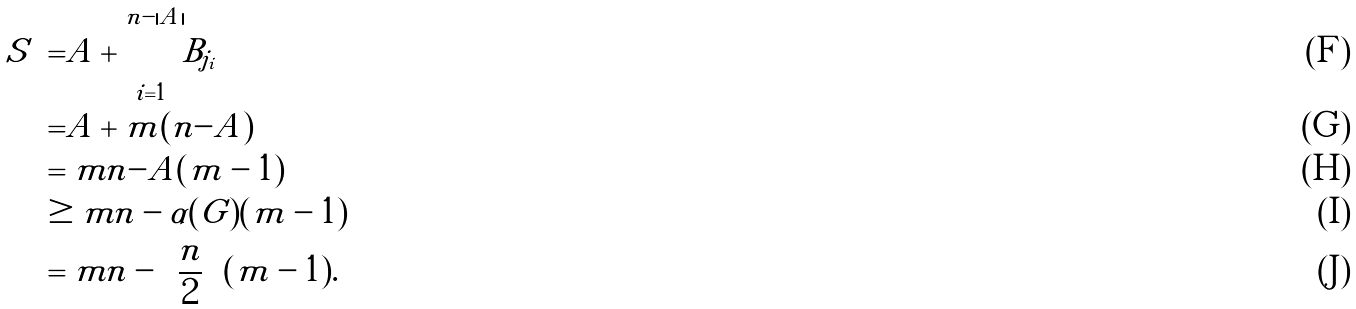Convert formula to latex. <formula><loc_0><loc_0><loc_500><loc_500>| S | & = | A | + \sum _ { i = 1 } ^ { n - | A | } | B _ { j _ { i } } | \\ & = | A | + m ( n - | A | ) \\ & = m n - | A | ( m - 1 ) \\ & \geq m n - \alpha ( G ) ( m - 1 ) \\ & = m n - \left \lceil \frac { n } { 2 } \right \rceil ( m - 1 ) .</formula> 